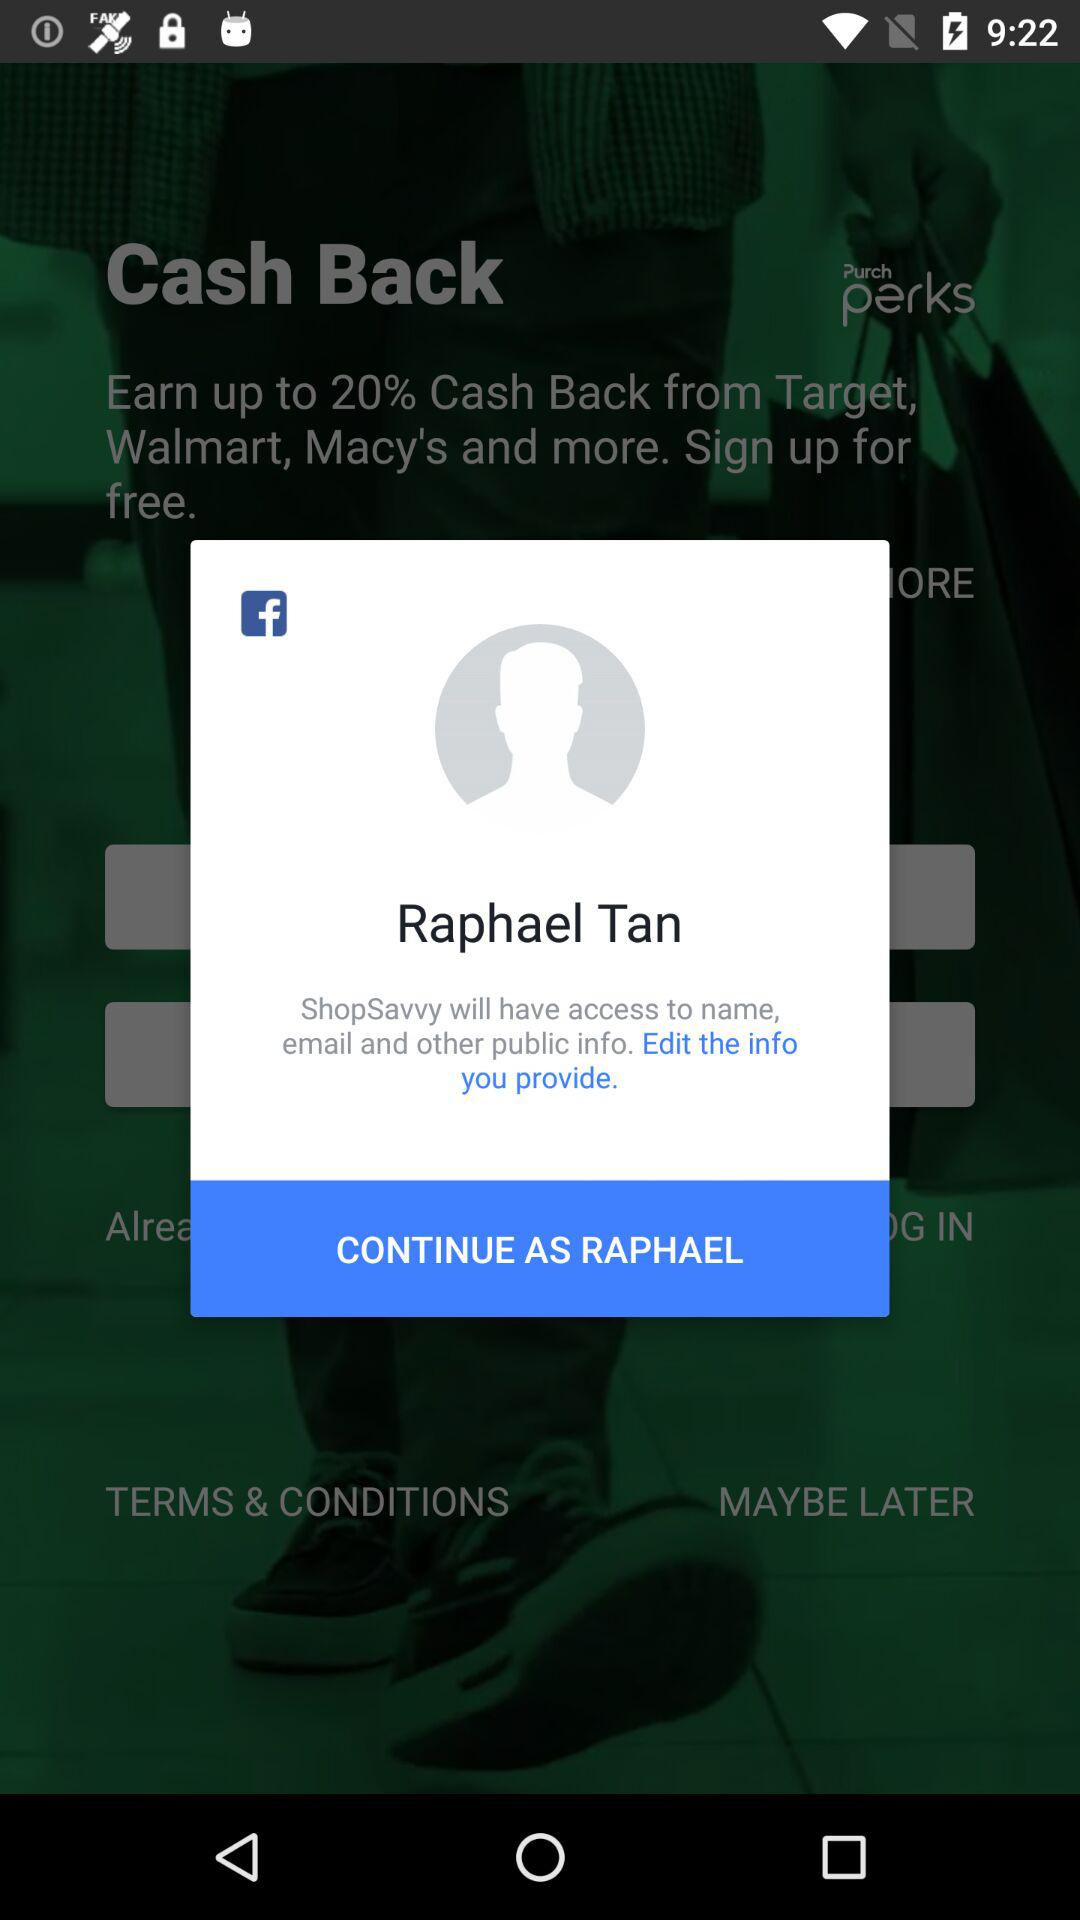Through what application can the user continue? The user can continue through "Facebook". 